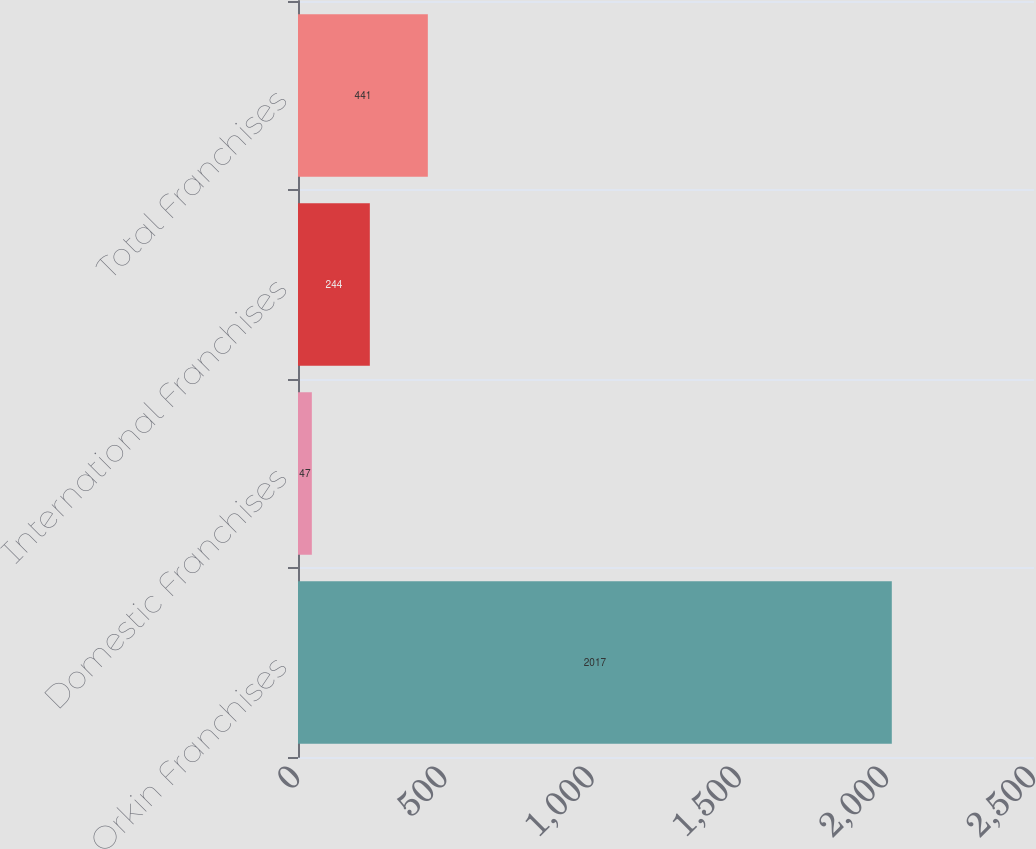<chart> <loc_0><loc_0><loc_500><loc_500><bar_chart><fcel>Orkin Franchises<fcel>Domestic Franchises<fcel>International Franchises<fcel>Total Franchises<nl><fcel>2017<fcel>47<fcel>244<fcel>441<nl></chart> 